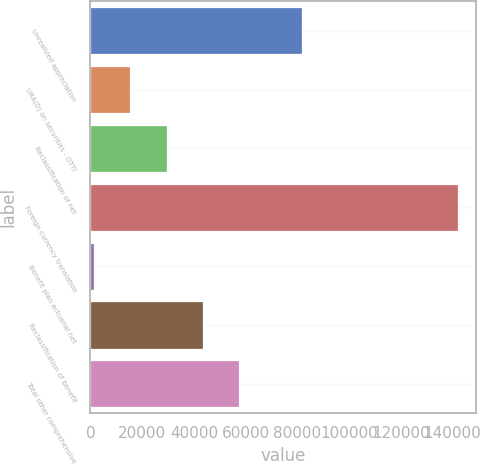Convert chart. <chart><loc_0><loc_0><loc_500><loc_500><bar_chart><fcel>Unrealized appreciation<fcel>URA(D) on securities - OTTI<fcel>Reclassification of net<fcel>Foreign currency translation<fcel>Benefit plan actuarial net<fcel>Reclassification of benefit<fcel>Total other comprehensive<nl><fcel>81915<fcel>15375.4<fcel>29450.8<fcel>142054<fcel>1300<fcel>43526.2<fcel>57601.6<nl></chart> 